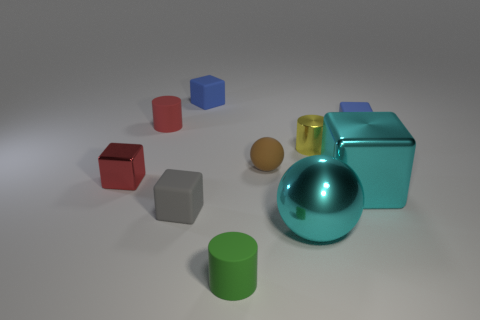Does the big block have the same color as the small metallic object that is right of the red shiny block?
Ensure brevity in your answer.  No. Do the metallic thing behind the tiny brown ball and the tiny sphere have the same color?
Provide a succinct answer. No. How many objects are either tiny gray objects or tiny blocks behind the big cyan metallic cube?
Your answer should be compact. 4. There is a block that is both in front of the small red block and on the right side of the small rubber ball; what is it made of?
Keep it short and to the point. Metal. What material is the green cylinder that is in front of the small brown object?
Ensure brevity in your answer.  Rubber. There is a ball that is the same material as the small gray object; what is its color?
Provide a succinct answer. Brown. There is a green matte thing; is it the same shape as the matte thing to the right of the yellow metal cylinder?
Provide a short and direct response. No. There is a small brown sphere; are there any things behind it?
Provide a short and direct response. Yes. What material is the thing that is the same color as the small metallic cube?
Make the answer very short. Rubber. There is a yellow metallic cylinder; is its size the same as the brown rubber sphere in front of the red rubber cylinder?
Ensure brevity in your answer.  Yes. 